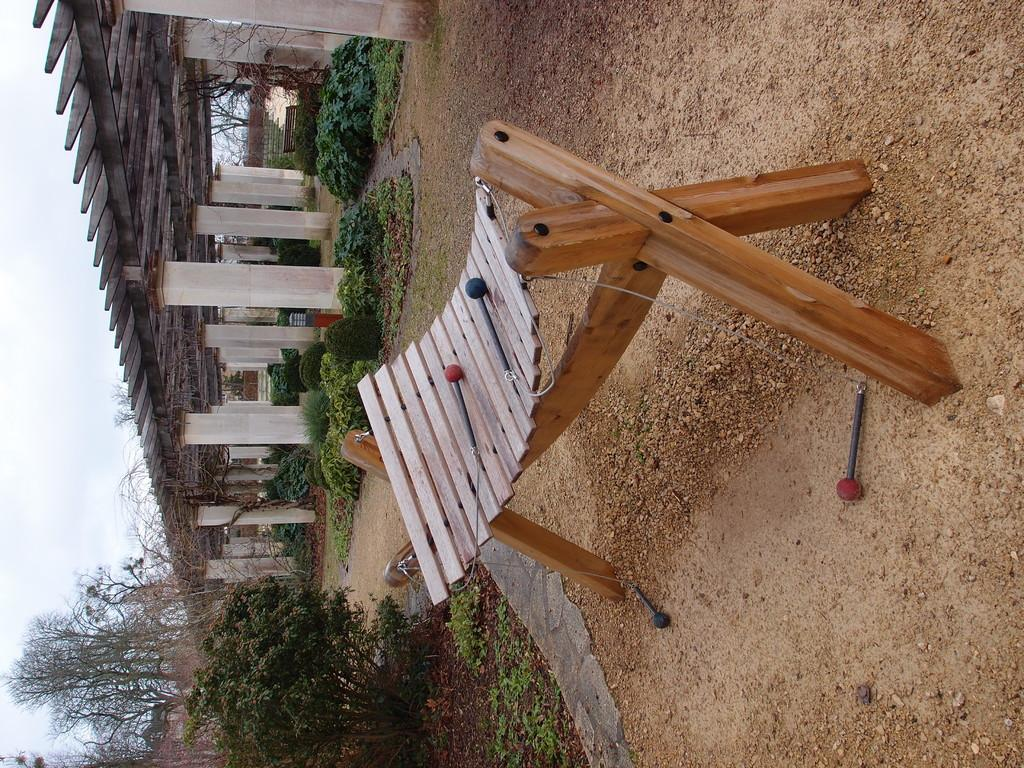What type of wooden object can be seen on the ground in the image? There is a wooden object on the ground in the image. What other natural elements are present in the image? There are plants and trees in the image. How many pillars can be seen in the image? There are many pillars in the image. What is attached to the pillars? Wooden sticks are present on the pillars. What type of temper do the boys in the image have? There are no boys present in the image, so it is not possible to determine their temper. 